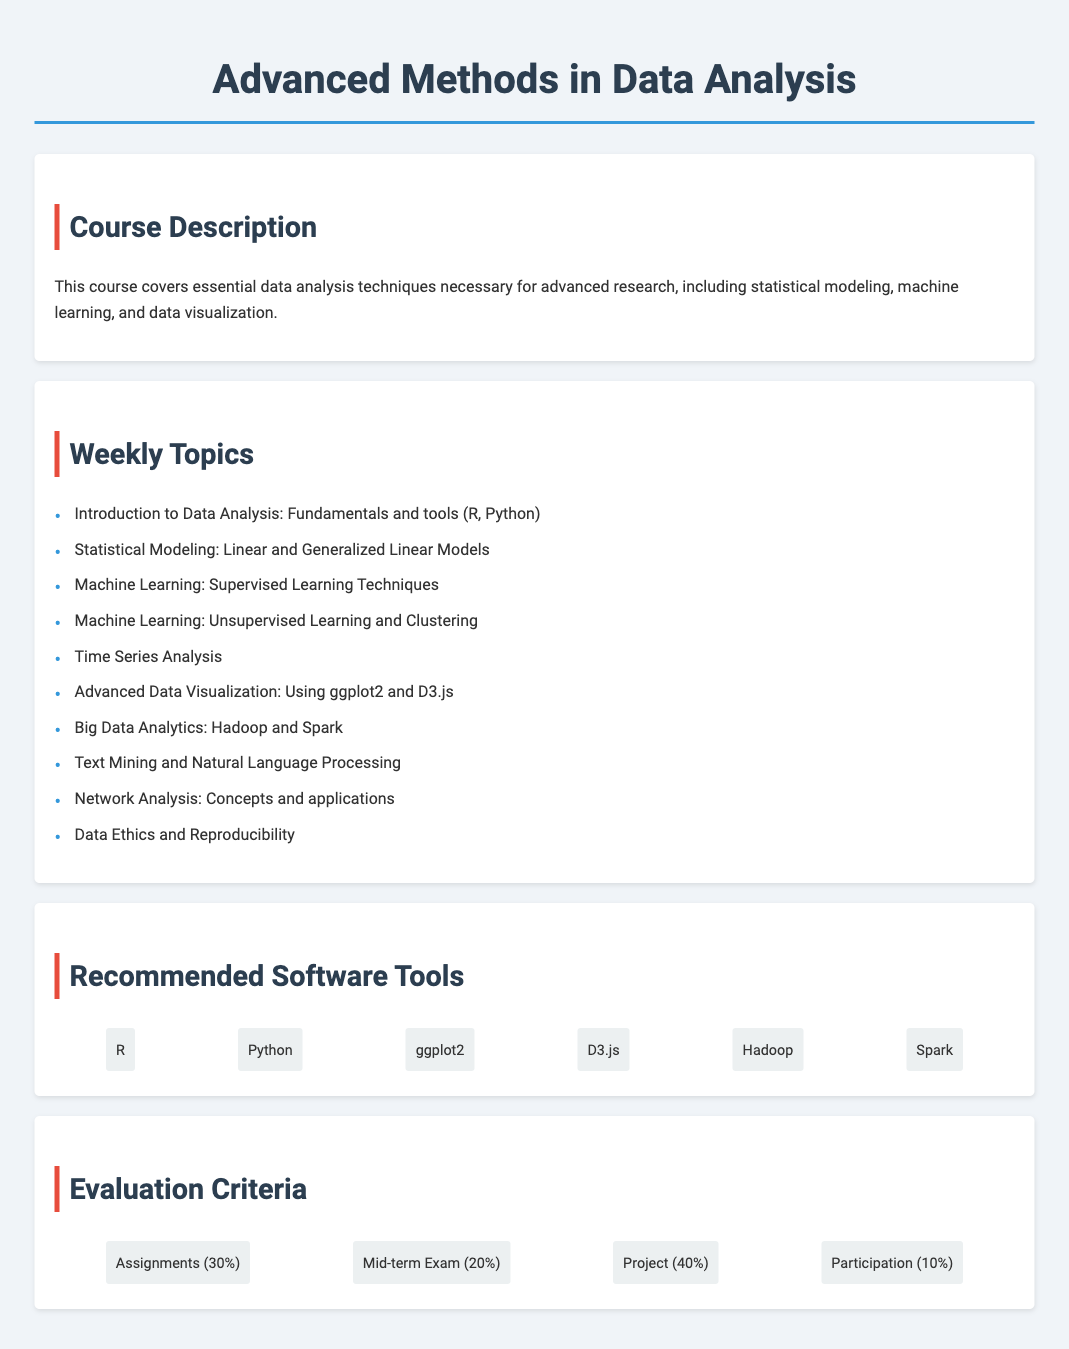What does the course cover? The course includes essential data analysis techniques necessary for advanced research.
Answer: Data analysis techniques What is one of the tools recommended for the course? The syllabus lists recommended software tools like R and Python for data analysis.
Answer: R How many weekly topics are outlined in the syllabus? The weekly topics section contains a list of ten distinct topics covered throughout the course.
Answer: 10 What percentage of the evaluation criteria is based on the project? The evaluation criteria allocates a portion of the total grade specifically towards the project component.
Answer: 40% What method is suggested for advanced data visualization? The syllabus recommends using specific software for creating advanced data visualizations.
Answer: ggplot2 What is the topic of the second week? The weekly topics detail specific subjects, with the second week focusing on statistical modeling.
Answer: Statistical Modeling What type of learning does the fourth week focus on? The syllabus specifies the types of machine learning techniques discussed in the fourth week.
Answer: Unsupervised Learning and Clustering What percentage is allocated for participation in the evaluation? The evaluation criteria detail how much of the total grade is determined by class participation.
Answer: 10% 